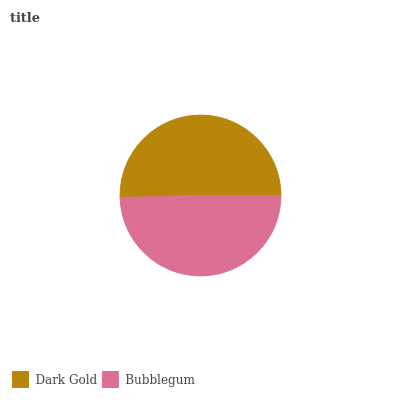Is Bubblegum the minimum?
Answer yes or no. Yes. Is Dark Gold the maximum?
Answer yes or no. Yes. Is Bubblegum the maximum?
Answer yes or no. No. Is Dark Gold greater than Bubblegum?
Answer yes or no. Yes. Is Bubblegum less than Dark Gold?
Answer yes or no. Yes. Is Bubblegum greater than Dark Gold?
Answer yes or no. No. Is Dark Gold less than Bubblegum?
Answer yes or no. No. Is Dark Gold the high median?
Answer yes or no. Yes. Is Bubblegum the low median?
Answer yes or no. Yes. Is Bubblegum the high median?
Answer yes or no. No. Is Dark Gold the low median?
Answer yes or no. No. 